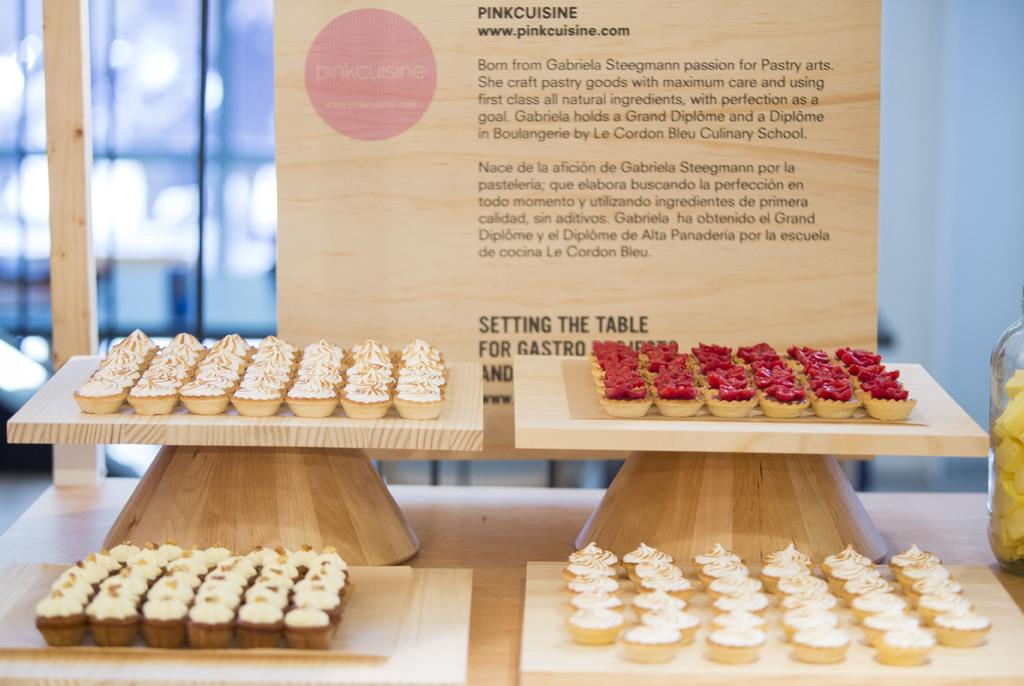What type of surface are the food items placed on in the image? The food items are placed on wooden boards in the image. What can be seen in the background of the image? There is a board visible in the background of the image. Where is the glass object located in the image? The glass object is on a wooden table on the right side of the image. What type of cast can be seen in the image? There is no cast present in the image. What type of harmony is depicted in the image? The image does not depict any specific harmony; it features food items on wooden boards and a glass object on a wooden table. 